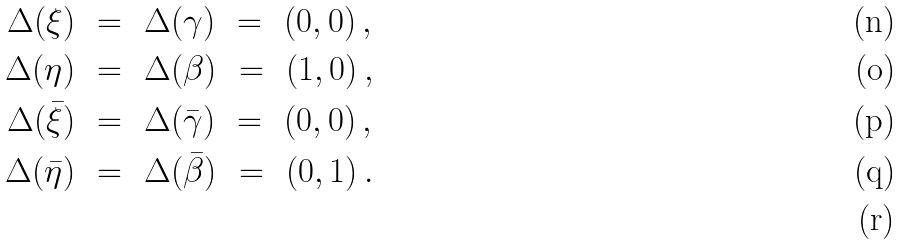<formula> <loc_0><loc_0><loc_500><loc_500>\Delta ( \xi ) \ & = \ \Delta ( \gamma ) \ = \ ( 0 , 0 ) \, , \\ \Delta ( \eta ) \ & = \ \Delta ( \beta ) \ = \ ( 1 , 0 ) \, , \\ \Delta ( \bar { \xi } ) \ & = \ \Delta ( \bar { \gamma } ) \ = \ ( 0 , 0 ) \, , \\ \Delta ( \bar { \eta } ) \ & = \ \Delta ( \bar { \beta } ) \ = \ ( 0 , 1 ) \, . \\</formula> 